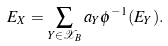Convert formula to latex. <formula><loc_0><loc_0><loc_500><loc_500>E _ { X } = \sum _ { Y \in \mathcal { X } _ { B } } { a _ { Y } \phi ^ { - 1 } ( E _ { Y } ) } .</formula> 